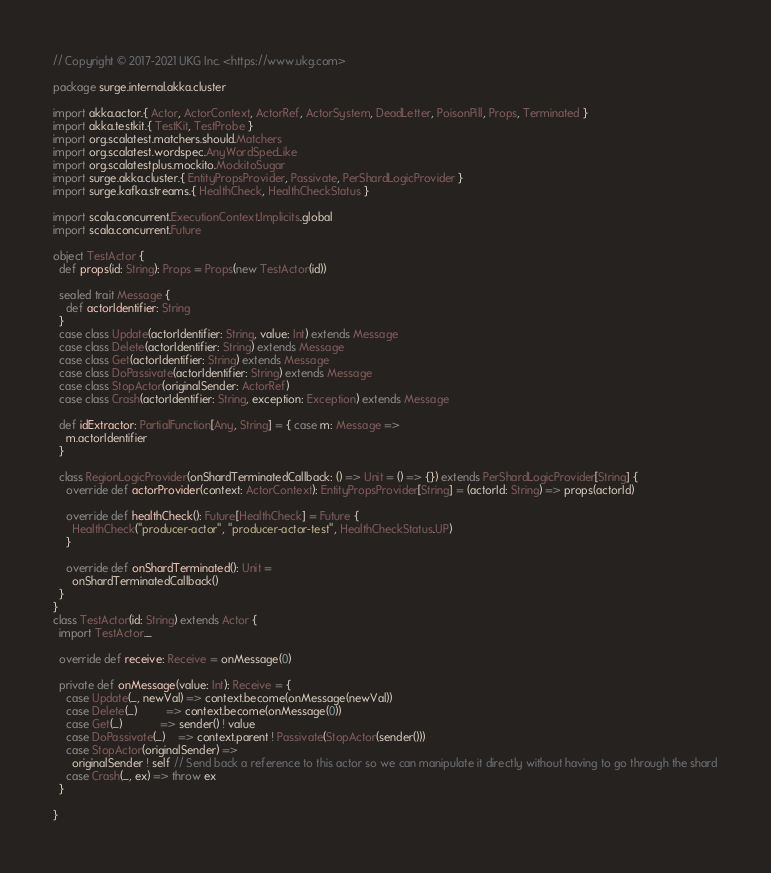Convert code to text. <code><loc_0><loc_0><loc_500><loc_500><_Scala_>// Copyright © 2017-2021 UKG Inc. <https://www.ukg.com>

package surge.internal.akka.cluster

import akka.actor.{ Actor, ActorContext, ActorRef, ActorSystem, DeadLetter, PoisonPill, Props, Terminated }
import akka.testkit.{ TestKit, TestProbe }
import org.scalatest.matchers.should.Matchers
import org.scalatest.wordspec.AnyWordSpecLike
import org.scalatestplus.mockito.MockitoSugar
import surge.akka.cluster.{ EntityPropsProvider, Passivate, PerShardLogicProvider }
import surge.kafka.streams.{ HealthCheck, HealthCheckStatus }

import scala.concurrent.ExecutionContext.Implicits.global
import scala.concurrent.Future

object TestActor {
  def props(id: String): Props = Props(new TestActor(id))

  sealed trait Message {
    def actorIdentifier: String
  }
  case class Update(actorIdentifier: String, value: Int) extends Message
  case class Delete(actorIdentifier: String) extends Message
  case class Get(actorIdentifier: String) extends Message
  case class DoPassivate(actorIdentifier: String) extends Message
  case class StopActor(originalSender: ActorRef)
  case class Crash(actorIdentifier: String, exception: Exception) extends Message

  def idExtractor: PartialFunction[Any, String] = { case m: Message =>
    m.actorIdentifier
  }

  class RegionLogicProvider(onShardTerminatedCallback: () => Unit = () => {}) extends PerShardLogicProvider[String] {
    override def actorProvider(context: ActorContext): EntityPropsProvider[String] = (actorId: String) => props(actorId)

    override def healthCheck(): Future[HealthCheck] = Future {
      HealthCheck("producer-actor", "producer-actor-test", HealthCheckStatus.UP)
    }

    override def onShardTerminated(): Unit =
      onShardTerminatedCallback()
  }
}
class TestActor(id: String) extends Actor {
  import TestActor._

  override def receive: Receive = onMessage(0)

  private def onMessage(value: Int): Receive = {
    case Update(_, newVal) => context.become(onMessage(newVal))
    case Delete(_)         => context.become(onMessage(0))
    case Get(_)            => sender() ! value
    case DoPassivate(_)    => context.parent ! Passivate(StopActor(sender()))
    case StopActor(originalSender) =>
      originalSender ! self // Send back a reference to this actor so we can manipulate it directly without having to go through the shard
    case Crash(_, ex) => throw ex
  }

}
</code> 